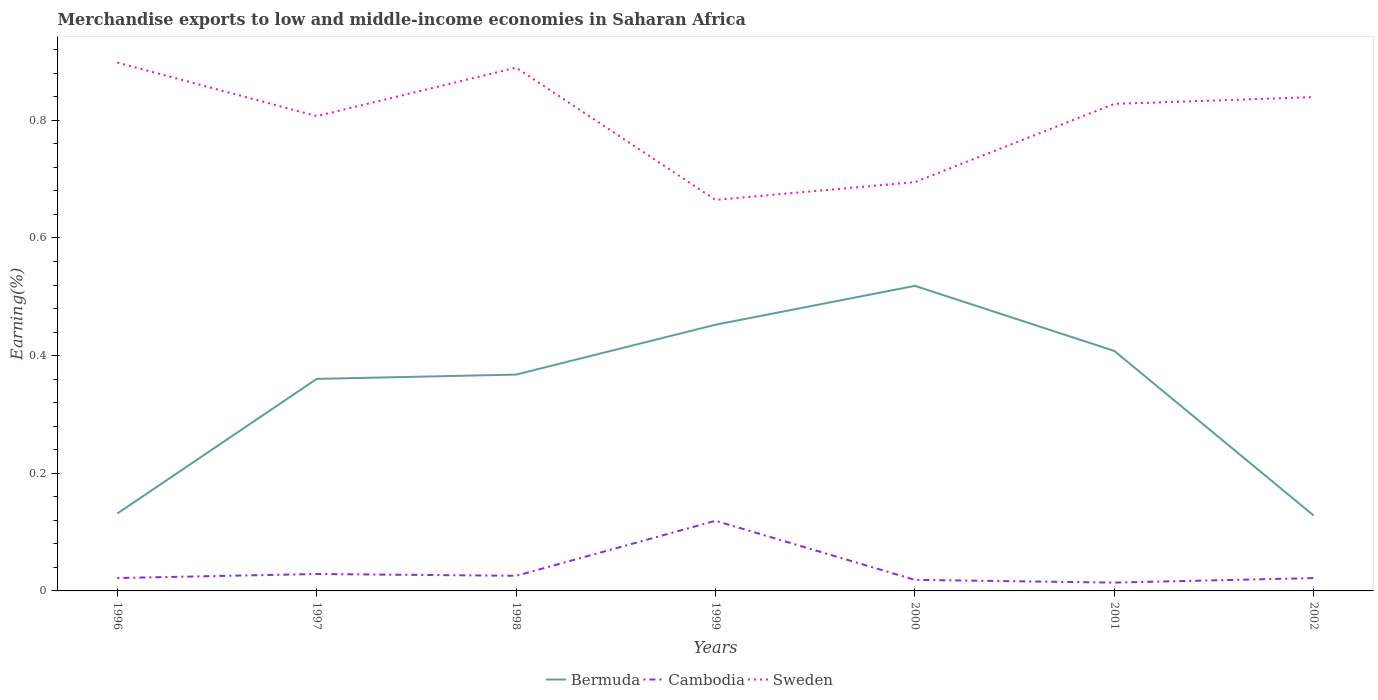How many different coloured lines are there?
Make the answer very short. 3. Is the number of lines equal to the number of legend labels?
Offer a very short reply. Yes. Across all years, what is the maximum percentage of amount earned from merchandise exports in Cambodia?
Your answer should be compact. 0.01. What is the total percentage of amount earned from merchandise exports in Cambodia in the graph?
Keep it short and to the point. 0.01. What is the difference between the highest and the second highest percentage of amount earned from merchandise exports in Bermuda?
Your answer should be very brief. 0.39. How many years are there in the graph?
Provide a succinct answer. 7. What is the difference between two consecutive major ticks on the Y-axis?
Ensure brevity in your answer.  0.2. Are the values on the major ticks of Y-axis written in scientific E-notation?
Offer a very short reply. No. Does the graph contain any zero values?
Keep it short and to the point. No. Where does the legend appear in the graph?
Your response must be concise. Bottom center. How many legend labels are there?
Your answer should be compact. 3. How are the legend labels stacked?
Keep it short and to the point. Horizontal. What is the title of the graph?
Your answer should be very brief. Merchandise exports to low and middle-income economies in Saharan Africa. Does "Dominica" appear as one of the legend labels in the graph?
Provide a succinct answer. No. What is the label or title of the X-axis?
Make the answer very short. Years. What is the label or title of the Y-axis?
Your answer should be compact. Earning(%). What is the Earning(%) of Bermuda in 1996?
Make the answer very short. 0.13. What is the Earning(%) in Cambodia in 1996?
Ensure brevity in your answer.  0.02. What is the Earning(%) in Sweden in 1996?
Keep it short and to the point. 0.9. What is the Earning(%) in Bermuda in 1997?
Keep it short and to the point. 0.36. What is the Earning(%) in Cambodia in 1997?
Make the answer very short. 0.03. What is the Earning(%) in Sweden in 1997?
Give a very brief answer. 0.81. What is the Earning(%) in Bermuda in 1998?
Your answer should be very brief. 0.37. What is the Earning(%) in Cambodia in 1998?
Provide a succinct answer. 0.03. What is the Earning(%) in Sweden in 1998?
Provide a short and direct response. 0.89. What is the Earning(%) of Bermuda in 1999?
Provide a succinct answer. 0.45. What is the Earning(%) in Cambodia in 1999?
Keep it short and to the point. 0.12. What is the Earning(%) of Sweden in 1999?
Keep it short and to the point. 0.66. What is the Earning(%) in Bermuda in 2000?
Your answer should be compact. 0.52. What is the Earning(%) in Cambodia in 2000?
Offer a terse response. 0.02. What is the Earning(%) in Sweden in 2000?
Ensure brevity in your answer.  0.69. What is the Earning(%) of Bermuda in 2001?
Make the answer very short. 0.41. What is the Earning(%) in Cambodia in 2001?
Provide a short and direct response. 0.01. What is the Earning(%) of Sweden in 2001?
Make the answer very short. 0.83. What is the Earning(%) of Bermuda in 2002?
Offer a very short reply. 0.13. What is the Earning(%) in Cambodia in 2002?
Your response must be concise. 0.02. What is the Earning(%) in Sweden in 2002?
Offer a terse response. 0.84. Across all years, what is the maximum Earning(%) of Bermuda?
Your answer should be very brief. 0.52. Across all years, what is the maximum Earning(%) of Cambodia?
Your answer should be very brief. 0.12. Across all years, what is the maximum Earning(%) in Sweden?
Your answer should be very brief. 0.9. Across all years, what is the minimum Earning(%) in Bermuda?
Your answer should be compact. 0.13. Across all years, what is the minimum Earning(%) in Cambodia?
Your answer should be compact. 0.01. Across all years, what is the minimum Earning(%) in Sweden?
Offer a terse response. 0.66. What is the total Earning(%) of Bermuda in the graph?
Ensure brevity in your answer.  2.37. What is the total Earning(%) in Cambodia in the graph?
Keep it short and to the point. 0.25. What is the total Earning(%) in Sweden in the graph?
Give a very brief answer. 5.62. What is the difference between the Earning(%) of Bermuda in 1996 and that in 1997?
Your answer should be compact. -0.23. What is the difference between the Earning(%) in Cambodia in 1996 and that in 1997?
Give a very brief answer. -0.01. What is the difference between the Earning(%) in Sweden in 1996 and that in 1997?
Offer a terse response. 0.09. What is the difference between the Earning(%) of Bermuda in 1996 and that in 1998?
Offer a very short reply. -0.24. What is the difference between the Earning(%) of Cambodia in 1996 and that in 1998?
Your answer should be very brief. -0. What is the difference between the Earning(%) in Sweden in 1996 and that in 1998?
Provide a succinct answer. 0.01. What is the difference between the Earning(%) of Bermuda in 1996 and that in 1999?
Provide a succinct answer. -0.32. What is the difference between the Earning(%) in Cambodia in 1996 and that in 1999?
Offer a very short reply. -0.1. What is the difference between the Earning(%) of Sweden in 1996 and that in 1999?
Offer a terse response. 0.23. What is the difference between the Earning(%) of Bermuda in 1996 and that in 2000?
Give a very brief answer. -0.39. What is the difference between the Earning(%) of Cambodia in 1996 and that in 2000?
Offer a very short reply. 0. What is the difference between the Earning(%) of Sweden in 1996 and that in 2000?
Ensure brevity in your answer.  0.2. What is the difference between the Earning(%) in Bermuda in 1996 and that in 2001?
Provide a succinct answer. -0.28. What is the difference between the Earning(%) of Cambodia in 1996 and that in 2001?
Your response must be concise. 0.01. What is the difference between the Earning(%) in Sweden in 1996 and that in 2001?
Keep it short and to the point. 0.07. What is the difference between the Earning(%) in Bermuda in 1996 and that in 2002?
Your response must be concise. 0. What is the difference between the Earning(%) of Cambodia in 1996 and that in 2002?
Offer a terse response. 0. What is the difference between the Earning(%) of Sweden in 1996 and that in 2002?
Your answer should be compact. 0.06. What is the difference between the Earning(%) in Bermuda in 1997 and that in 1998?
Provide a succinct answer. -0.01. What is the difference between the Earning(%) of Cambodia in 1997 and that in 1998?
Give a very brief answer. 0. What is the difference between the Earning(%) of Sweden in 1997 and that in 1998?
Offer a very short reply. -0.08. What is the difference between the Earning(%) in Bermuda in 1997 and that in 1999?
Your answer should be very brief. -0.09. What is the difference between the Earning(%) in Cambodia in 1997 and that in 1999?
Offer a very short reply. -0.09. What is the difference between the Earning(%) in Sweden in 1997 and that in 1999?
Your answer should be compact. 0.14. What is the difference between the Earning(%) in Bermuda in 1997 and that in 2000?
Provide a short and direct response. -0.16. What is the difference between the Earning(%) in Sweden in 1997 and that in 2000?
Your response must be concise. 0.11. What is the difference between the Earning(%) in Bermuda in 1997 and that in 2001?
Provide a short and direct response. -0.05. What is the difference between the Earning(%) in Cambodia in 1997 and that in 2001?
Offer a terse response. 0.01. What is the difference between the Earning(%) of Sweden in 1997 and that in 2001?
Give a very brief answer. -0.02. What is the difference between the Earning(%) in Bermuda in 1997 and that in 2002?
Give a very brief answer. 0.23. What is the difference between the Earning(%) in Cambodia in 1997 and that in 2002?
Offer a very short reply. 0.01. What is the difference between the Earning(%) in Sweden in 1997 and that in 2002?
Ensure brevity in your answer.  -0.03. What is the difference between the Earning(%) in Bermuda in 1998 and that in 1999?
Offer a very short reply. -0.08. What is the difference between the Earning(%) in Cambodia in 1998 and that in 1999?
Your response must be concise. -0.09. What is the difference between the Earning(%) in Sweden in 1998 and that in 1999?
Your answer should be compact. 0.22. What is the difference between the Earning(%) in Bermuda in 1998 and that in 2000?
Give a very brief answer. -0.15. What is the difference between the Earning(%) of Cambodia in 1998 and that in 2000?
Provide a succinct answer. 0.01. What is the difference between the Earning(%) of Sweden in 1998 and that in 2000?
Offer a very short reply. 0.19. What is the difference between the Earning(%) in Bermuda in 1998 and that in 2001?
Ensure brevity in your answer.  -0.04. What is the difference between the Earning(%) in Cambodia in 1998 and that in 2001?
Make the answer very short. 0.01. What is the difference between the Earning(%) in Sweden in 1998 and that in 2001?
Keep it short and to the point. 0.06. What is the difference between the Earning(%) of Bermuda in 1998 and that in 2002?
Provide a succinct answer. 0.24. What is the difference between the Earning(%) in Cambodia in 1998 and that in 2002?
Make the answer very short. 0. What is the difference between the Earning(%) in Sweden in 1998 and that in 2002?
Provide a short and direct response. 0.05. What is the difference between the Earning(%) in Bermuda in 1999 and that in 2000?
Your response must be concise. -0.07. What is the difference between the Earning(%) of Cambodia in 1999 and that in 2000?
Keep it short and to the point. 0.1. What is the difference between the Earning(%) of Sweden in 1999 and that in 2000?
Your answer should be very brief. -0.03. What is the difference between the Earning(%) in Bermuda in 1999 and that in 2001?
Provide a succinct answer. 0.04. What is the difference between the Earning(%) in Cambodia in 1999 and that in 2001?
Your answer should be compact. 0.11. What is the difference between the Earning(%) in Sweden in 1999 and that in 2001?
Your answer should be compact. -0.16. What is the difference between the Earning(%) in Bermuda in 1999 and that in 2002?
Offer a very short reply. 0.32. What is the difference between the Earning(%) in Cambodia in 1999 and that in 2002?
Keep it short and to the point. 0.1. What is the difference between the Earning(%) in Sweden in 1999 and that in 2002?
Your answer should be compact. -0.17. What is the difference between the Earning(%) in Bermuda in 2000 and that in 2001?
Keep it short and to the point. 0.11. What is the difference between the Earning(%) in Cambodia in 2000 and that in 2001?
Offer a terse response. 0. What is the difference between the Earning(%) in Sweden in 2000 and that in 2001?
Offer a very short reply. -0.13. What is the difference between the Earning(%) in Bermuda in 2000 and that in 2002?
Your answer should be very brief. 0.39. What is the difference between the Earning(%) of Cambodia in 2000 and that in 2002?
Provide a succinct answer. -0. What is the difference between the Earning(%) of Sweden in 2000 and that in 2002?
Your answer should be compact. -0.14. What is the difference between the Earning(%) in Bermuda in 2001 and that in 2002?
Give a very brief answer. 0.28. What is the difference between the Earning(%) in Cambodia in 2001 and that in 2002?
Make the answer very short. -0.01. What is the difference between the Earning(%) of Sweden in 2001 and that in 2002?
Offer a very short reply. -0.01. What is the difference between the Earning(%) of Bermuda in 1996 and the Earning(%) of Cambodia in 1997?
Provide a short and direct response. 0.1. What is the difference between the Earning(%) in Bermuda in 1996 and the Earning(%) in Sweden in 1997?
Keep it short and to the point. -0.68. What is the difference between the Earning(%) in Cambodia in 1996 and the Earning(%) in Sweden in 1997?
Make the answer very short. -0.79. What is the difference between the Earning(%) in Bermuda in 1996 and the Earning(%) in Cambodia in 1998?
Your response must be concise. 0.11. What is the difference between the Earning(%) of Bermuda in 1996 and the Earning(%) of Sweden in 1998?
Provide a succinct answer. -0.76. What is the difference between the Earning(%) of Cambodia in 1996 and the Earning(%) of Sweden in 1998?
Ensure brevity in your answer.  -0.87. What is the difference between the Earning(%) in Bermuda in 1996 and the Earning(%) in Cambodia in 1999?
Your answer should be compact. 0.01. What is the difference between the Earning(%) in Bermuda in 1996 and the Earning(%) in Sweden in 1999?
Offer a terse response. -0.53. What is the difference between the Earning(%) of Cambodia in 1996 and the Earning(%) of Sweden in 1999?
Give a very brief answer. -0.64. What is the difference between the Earning(%) in Bermuda in 1996 and the Earning(%) in Cambodia in 2000?
Give a very brief answer. 0.11. What is the difference between the Earning(%) in Bermuda in 1996 and the Earning(%) in Sweden in 2000?
Make the answer very short. -0.56. What is the difference between the Earning(%) of Cambodia in 1996 and the Earning(%) of Sweden in 2000?
Your answer should be very brief. -0.67. What is the difference between the Earning(%) in Bermuda in 1996 and the Earning(%) in Cambodia in 2001?
Provide a succinct answer. 0.12. What is the difference between the Earning(%) of Bermuda in 1996 and the Earning(%) of Sweden in 2001?
Make the answer very short. -0.7. What is the difference between the Earning(%) of Cambodia in 1996 and the Earning(%) of Sweden in 2001?
Offer a very short reply. -0.81. What is the difference between the Earning(%) of Bermuda in 1996 and the Earning(%) of Cambodia in 2002?
Your response must be concise. 0.11. What is the difference between the Earning(%) of Bermuda in 1996 and the Earning(%) of Sweden in 2002?
Provide a succinct answer. -0.71. What is the difference between the Earning(%) of Cambodia in 1996 and the Earning(%) of Sweden in 2002?
Make the answer very short. -0.82. What is the difference between the Earning(%) of Bermuda in 1997 and the Earning(%) of Cambodia in 1998?
Provide a short and direct response. 0.33. What is the difference between the Earning(%) of Bermuda in 1997 and the Earning(%) of Sweden in 1998?
Your answer should be compact. -0.53. What is the difference between the Earning(%) of Cambodia in 1997 and the Earning(%) of Sweden in 1998?
Provide a short and direct response. -0.86. What is the difference between the Earning(%) of Bermuda in 1997 and the Earning(%) of Cambodia in 1999?
Your answer should be very brief. 0.24. What is the difference between the Earning(%) of Bermuda in 1997 and the Earning(%) of Sweden in 1999?
Your answer should be compact. -0.3. What is the difference between the Earning(%) of Cambodia in 1997 and the Earning(%) of Sweden in 1999?
Your response must be concise. -0.64. What is the difference between the Earning(%) of Bermuda in 1997 and the Earning(%) of Cambodia in 2000?
Your answer should be very brief. 0.34. What is the difference between the Earning(%) in Bermuda in 1997 and the Earning(%) in Sweden in 2000?
Make the answer very short. -0.33. What is the difference between the Earning(%) in Cambodia in 1997 and the Earning(%) in Sweden in 2000?
Provide a succinct answer. -0.67. What is the difference between the Earning(%) in Bermuda in 1997 and the Earning(%) in Cambodia in 2001?
Provide a short and direct response. 0.35. What is the difference between the Earning(%) in Bermuda in 1997 and the Earning(%) in Sweden in 2001?
Your answer should be very brief. -0.47. What is the difference between the Earning(%) in Cambodia in 1997 and the Earning(%) in Sweden in 2001?
Provide a succinct answer. -0.8. What is the difference between the Earning(%) in Bermuda in 1997 and the Earning(%) in Cambodia in 2002?
Make the answer very short. 0.34. What is the difference between the Earning(%) in Bermuda in 1997 and the Earning(%) in Sweden in 2002?
Your response must be concise. -0.48. What is the difference between the Earning(%) of Cambodia in 1997 and the Earning(%) of Sweden in 2002?
Give a very brief answer. -0.81. What is the difference between the Earning(%) of Bermuda in 1998 and the Earning(%) of Cambodia in 1999?
Make the answer very short. 0.25. What is the difference between the Earning(%) in Bermuda in 1998 and the Earning(%) in Sweden in 1999?
Offer a terse response. -0.3. What is the difference between the Earning(%) of Cambodia in 1998 and the Earning(%) of Sweden in 1999?
Give a very brief answer. -0.64. What is the difference between the Earning(%) in Bermuda in 1998 and the Earning(%) in Cambodia in 2000?
Ensure brevity in your answer.  0.35. What is the difference between the Earning(%) in Bermuda in 1998 and the Earning(%) in Sweden in 2000?
Keep it short and to the point. -0.33. What is the difference between the Earning(%) in Cambodia in 1998 and the Earning(%) in Sweden in 2000?
Keep it short and to the point. -0.67. What is the difference between the Earning(%) in Bermuda in 1998 and the Earning(%) in Cambodia in 2001?
Your answer should be compact. 0.35. What is the difference between the Earning(%) of Bermuda in 1998 and the Earning(%) of Sweden in 2001?
Ensure brevity in your answer.  -0.46. What is the difference between the Earning(%) of Cambodia in 1998 and the Earning(%) of Sweden in 2001?
Offer a terse response. -0.8. What is the difference between the Earning(%) in Bermuda in 1998 and the Earning(%) in Cambodia in 2002?
Ensure brevity in your answer.  0.35. What is the difference between the Earning(%) of Bermuda in 1998 and the Earning(%) of Sweden in 2002?
Keep it short and to the point. -0.47. What is the difference between the Earning(%) in Cambodia in 1998 and the Earning(%) in Sweden in 2002?
Your answer should be very brief. -0.81. What is the difference between the Earning(%) in Bermuda in 1999 and the Earning(%) in Cambodia in 2000?
Keep it short and to the point. 0.43. What is the difference between the Earning(%) in Bermuda in 1999 and the Earning(%) in Sweden in 2000?
Your answer should be compact. -0.24. What is the difference between the Earning(%) of Cambodia in 1999 and the Earning(%) of Sweden in 2000?
Offer a very short reply. -0.58. What is the difference between the Earning(%) of Bermuda in 1999 and the Earning(%) of Cambodia in 2001?
Make the answer very short. 0.44. What is the difference between the Earning(%) in Bermuda in 1999 and the Earning(%) in Sweden in 2001?
Make the answer very short. -0.38. What is the difference between the Earning(%) in Cambodia in 1999 and the Earning(%) in Sweden in 2001?
Provide a short and direct response. -0.71. What is the difference between the Earning(%) of Bermuda in 1999 and the Earning(%) of Cambodia in 2002?
Offer a very short reply. 0.43. What is the difference between the Earning(%) in Bermuda in 1999 and the Earning(%) in Sweden in 2002?
Provide a short and direct response. -0.39. What is the difference between the Earning(%) of Cambodia in 1999 and the Earning(%) of Sweden in 2002?
Provide a succinct answer. -0.72. What is the difference between the Earning(%) of Bermuda in 2000 and the Earning(%) of Cambodia in 2001?
Offer a very short reply. 0.5. What is the difference between the Earning(%) of Bermuda in 2000 and the Earning(%) of Sweden in 2001?
Offer a very short reply. -0.31. What is the difference between the Earning(%) of Cambodia in 2000 and the Earning(%) of Sweden in 2001?
Provide a succinct answer. -0.81. What is the difference between the Earning(%) of Bermuda in 2000 and the Earning(%) of Cambodia in 2002?
Your answer should be compact. 0.5. What is the difference between the Earning(%) in Bermuda in 2000 and the Earning(%) in Sweden in 2002?
Offer a terse response. -0.32. What is the difference between the Earning(%) of Cambodia in 2000 and the Earning(%) of Sweden in 2002?
Keep it short and to the point. -0.82. What is the difference between the Earning(%) in Bermuda in 2001 and the Earning(%) in Cambodia in 2002?
Provide a short and direct response. 0.39. What is the difference between the Earning(%) in Bermuda in 2001 and the Earning(%) in Sweden in 2002?
Your answer should be compact. -0.43. What is the difference between the Earning(%) of Cambodia in 2001 and the Earning(%) of Sweden in 2002?
Give a very brief answer. -0.83. What is the average Earning(%) in Bermuda per year?
Provide a short and direct response. 0.34. What is the average Earning(%) of Cambodia per year?
Give a very brief answer. 0.04. What is the average Earning(%) in Sweden per year?
Make the answer very short. 0.8. In the year 1996, what is the difference between the Earning(%) of Bermuda and Earning(%) of Cambodia?
Ensure brevity in your answer.  0.11. In the year 1996, what is the difference between the Earning(%) of Bermuda and Earning(%) of Sweden?
Offer a very short reply. -0.77. In the year 1996, what is the difference between the Earning(%) of Cambodia and Earning(%) of Sweden?
Your answer should be very brief. -0.88. In the year 1997, what is the difference between the Earning(%) in Bermuda and Earning(%) in Cambodia?
Your response must be concise. 0.33. In the year 1997, what is the difference between the Earning(%) of Bermuda and Earning(%) of Sweden?
Keep it short and to the point. -0.45. In the year 1997, what is the difference between the Earning(%) of Cambodia and Earning(%) of Sweden?
Your answer should be very brief. -0.78. In the year 1998, what is the difference between the Earning(%) of Bermuda and Earning(%) of Cambodia?
Keep it short and to the point. 0.34. In the year 1998, what is the difference between the Earning(%) in Bermuda and Earning(%) in Sweden?
Offer a terse response. -0.52. In the year 1998, what is the difference between the Earning(%) of Cambodia and Earning(%) of Sweden?
Ensure brevity in your answer.  -0.86. In the year 1999, what is the difference between the Earning(%) in Bermuda and Earning(%) in Cambodia?
Your response must be concise. 0.33. In the year 1999, what is the difference between the Earning(%) of Bermuda and Earning(%) of Sweden?
Keep it short and to the point. -0.21. In the year 1999, what is the difference between the Earning(%) in Cambodia and Earning(%) in Sweden?
Give a very brief answer. -0.55. In the year 2000, what is the difference between the Earning(%) of Bermuda and Earning(%) of Cambodia?
Make the answer very short. 0.5. In the year 2000, what is the difference between the Earning(%) of Bermuda and Earning(%) of Sweden?
Make the answer very short. -0.18. In the year 2000, what is the difference between the Earning(%) of Cambodia and Earning(%) of Sweden?
Your response must be concise. -0.68. In the year 2001, what is the difference between the Earning(%) of Bermuda and Earning(%) of Cambodia?
Provide a succinct answer. 0.39. In the year 2001, what is the difference between the Earning(%) in Bermuda and Earning(%) in Sweden?
Provide a succinct answer. -0.42. In the year 2001, what is the difference between the Earning(%) in Cambodia and Earning(%) in Sweden?
Offer a terse response. -0.81. In the year 2002, what is the difference between the Earning(%) of Bermuda and Earning(%) of Cambodia?
Your answer should be very brief. 0.11. In the year 2002, what is the difference between the Earning(%) of Bermuda and Earning(%) of Sweden?
Your answer should be very brief. -0.71. In the year 2002, what is the difference between the Earning(%) in Cambodia and Earning(%) in Sweden?
Offer a very short reply. -0.82. What is the ratio of the Earning(%) in Bermuda in 1996 to that in 1997?
Your answer should be compact. 0.37. What is the ratio of the Earning(%) of Cambodia in 1996 to that in 1997?
Provide a short and direct response. 0.76. What is the ratio of the Earning(%) of Sweden in 1996 to that in 1997?
Offer a very short reply. 1.11. What is the ratio of the Earning(%) of Bermuda in 1996 to that in 1998?
Make the answer very short. 0.36. What is the ratio of the Earning(%) of Cambodia in 1996 to that in 1998?
Your answer should be very brief. 0.85. What is the ratio of the Earning(%) in Sweden in 1996 to that in 1998?
Offer a very short reply. 1.01. What is the ratio of the Earning(%) in Bermuda in 1996 to that in 1999?
Make the answer very short. 0.29. What is the ratio of the Earning(%) of Cambodia in 1996 to that in 1999?
Ensure brevity in your answer.  0.18. What is the ratio of the Earning(%) of Sweden in 1996 to that in 1999?
Provide a succinct answer. 1.35. What is the ratio of the Earning(%) of Bermuda in 1996 to that in 2000?
Your answer should be compact. 0.25. What is the ratio of the Earning(%) of Cambodia in 1996 to that in 2000?
Offer a very short reply. 1.17. What is the ratio of the Earning(%) of Sweden in 1996 to that in 2000?
Offer a very short reply. 1.29. What is the ratio of the Earning(%) in Bermuda in 1996 to that in 2001?
Offer a very short reply. 0.32. What is the ratio of the Earning(%) in Cambodia in 1996 to that in 2001?
Your answer should be very brief. 1.55. What is the ratio of the Earning(%) in Sweden in 1996 to that in 2001?
Your answer should be compact. 1.08. What is the ratio of the Earning(%) in Bermuda in 1996 to that in 2002?
Your response must be concise. 1.03. What is the ratio of the Earning(%) in Cambodia in 1996 to that in 2002?
Make the answer very short. 1. What is the ratio of the Earning(%) of Sweden in 1996 to that in 2002?
Provide a short and direct response. 1.07. What is the ratio of the Earning(%) of Bermuda in 1997 to that in 1998?
Your answer should be compact. 0.98. What is the ratio of the Earning(%) of Cambodia in 1997 to that in 1998?
Offer a terse response. 1.12. What is the ratio of the Earning(%) in Sweden in 1997 to that in 1998?
Keep it short and to the point. 0.91. What is the ratio of the Earning(%) in Bermuda in 1997 to that in 1999?
Provide a short and direct response. 0.8. What is the ratio of the Earning(%) of Cambodia in 1997 to that in 1999?
Your answer should be compact. 0.24. What is the ratio of the Earning(%) of Sweden in 1997 to that in 1999?
Offer a very short reply. 1.21. What is the ratio of the Earning(%) of Bermuda in 1997 to that in 2000?
Keep it short and to the point. 0.69. What is the ratio of the Earning(%) of Cambodia in 1997 to that in 2000?
Your answer should be very brief. 1.53. What is the ratio of the Earning(%) in Sweden in 1997 to that in 2000?
Make the answer very short. 1.16. What is the ratio of the Earning(%) in Bermuda in 1997 to that in 2001?
Give a very brief answer. 0.88. What is the ratio of the Earning(%) of Cambodia in 1997 to that in 2001?
Your answer should be compact. 2.03. What is the ratio of the Earning(%) in Sweden in 1997 to that in 2001?
Ensure brevity in your answer.  0.97. What is the ratio of the Earning(%) of Bermuda in 1997 to that in 2002?
Your response must be concise. 2.81. What is the ratio of the Earning(%) of Cambodia in 1997 to that in 2002?
Provide a short and direct response. 1.32. What is the ratio of the Earning(%) of Sweden in 1997 to that in 2002?
Provide a succinct answer. 0.96. What is the ratio of the Earning(%) of Bermuda in 1998 to that in 1999?
Offer a very short reply. 0.81. What is the ratio of the Earning(%) of Cambodia in 1998 to that in 1999?
Your response must be concise. 0.22. What is the ratio of the Earning(%) of Sweden in 1998 to that in 1999?
Make the answer very short. 1.34. What is the ratio of the Earning(%) of Bermuda in 1998 to that in 2000?
Ensure brevity in your answer.  0.71. What is the ratio of the Earning(%) in Cambodia in 1998 to that in 2000?
Make the answer very short. 1.37. What is the ratio of the Earning(%) of Sweden in 1998 to that in 2000?
Your response must be concise. 1.28. What is the ratio of the Earning(%) of Bermuda in 1998 to that in 2001?
Ensure brevity in your answer.  0.9. What is the ratio of the Earning(%) in Cambodia in 1998 to that in 2001?
Your answer should be very brief. 1.82. What is the ratio of the Earning(%) in Sweden in 1998 to that in 2001?
Provide a short and direct response. 1.07. What is the ratio of the Earning(%) in Bermuda in 1998 to that in 2002?
Ensure brevity in your answer.  2.87. What is the ratio of the Earning(%) of Cambodia in 1998 to that in 2002?
Ensure brevity in your answer.  1.18. What is the ratio of the Earning(%) in Sweden in 1998 to that in 2002?
Offer a terse response. 1.06. What is the ratio of the Earning(%) in Bermuda in 1999 to that in 2000?
Your answer should be compact. 0.87. What is the ratio of the Earning(%) of Cambodia in 1999 to that in 2000?
Offer a terse response. 6.35. What is the ratio of the Earning(%) of Sweden in 1999 to that in 2000?
Provide a succinct answer. 0.96. What is the ratio of the Earning(%) in Bermuda in 1999 to that in 2001?
Give a very brief answer. 1.11. What is the ratio of the Earning(%) of Cambodia in 1999 to that in 2001?
Your answer should be compact. 8.42. What is the ratio of the Earning(%) in Sweden in 1999 to that in 2001?
Make the answer very short. 0.8. What is the ratio of the Earning(%) of Bermuda in 1999 to that in 2002?
Offer a terse response. 3.53. What is the ratio of the Earning(%) of Cambodia in 1999 to that in 2002?
Give a very brief answer. 5.46. What is the ratio of the Earning(%) in Sweden in 1999 to that in 2002?
Provide a short and direct response. 0.79. What is the ratio of the Earning(%) in Bermuda in 2000 to that in 2001?
Your answer should be very brief. 1.27. What is the ratio of the Earning(%) of Cambodia in 2000 to that in 2001?
Provide a short and direct response. 1.33. What is the ratio of the Earning(%) in Sweden in 2000 to that in 2001?
Offer a very short reply. 0.84. What is the ratio of the Earning(%) of Bermuda in 2000 to that in 2002?
Your answer should be compact. 4.05. What is the ratio of the Earning(%) in Cambodia in 2000 to that in 2002?
Offer a very short reply. 0.86. What is the ratio of the Earning(%) in Sweden in 2000 to that in 2002?
Offer a very short reply. 0.83. What is the ratio of the Earning(%) of Bermuda in 2001 to that in 2002?
Offer a terse response. 3.18. What is the ratio of the Earning(%) of Cambodia in 2001 to that in 2002?
Keep it short and to the point. 0.65. What is the ratio of the Earning(%) in Sweden in 2001 to that in 2002?
Provide a succinct answer. 0.99. What is the difference between the highest and the second highest Earning(%) of Bermuda?
Your answer should be compact. 0.07. What is the difference between the highest and the second highest Earning(%) of Cambodia?
Your response must be concise. 0.09. What is the difference between the highest and the second highest Earning(%) in Sweden?
Give a very brief answer. 0.01. What is the difference between the highest and the lowest Earning(%) of Bermuda?
Provide a short and direct response. 0.39. What is the difference between the highest and the lowest Earning(%) in Cambodia?
Provide a succinct answer. 0.11. What is the difference between the highest and the lowest Earning(%) in Sweden?
Make the answer very short. 0.23. 